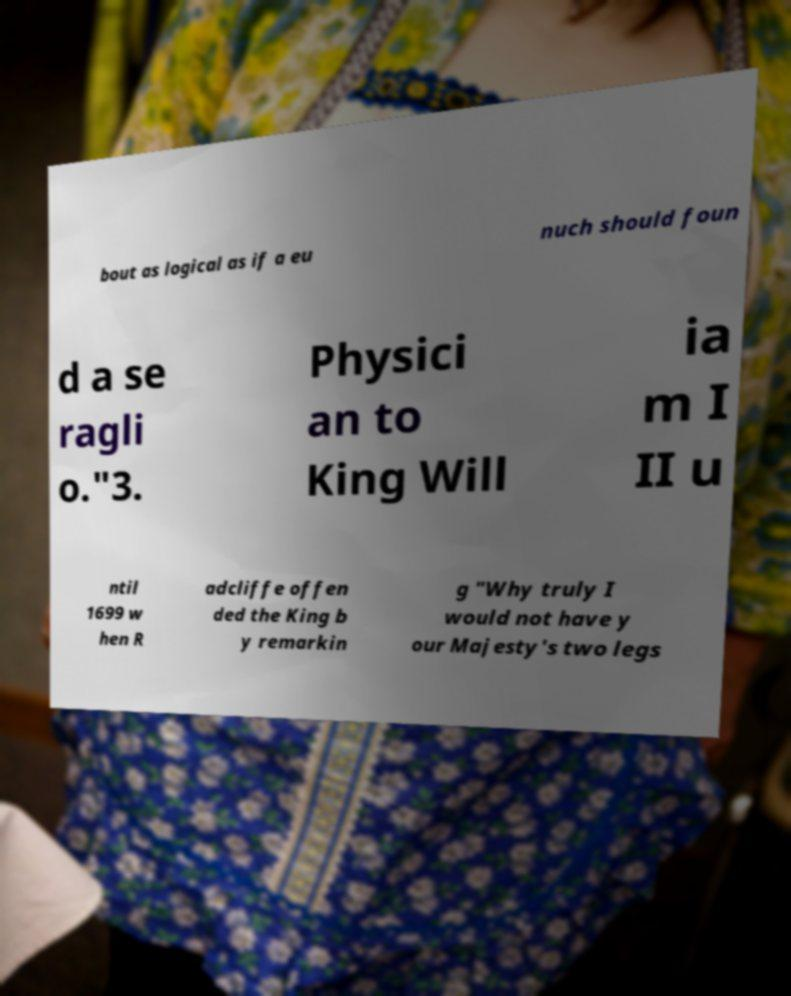For documentation purposes, I need the text within this image transcribed. Could you provide that? bout as logical as if a eu nuch should foun d a se ragli o."3. Physici an to King Will ia m I II u ntil 1699 w hen R adcliffe offen ded the King b y remarkin g "Why truly I would not have y our Majesty's two legs 